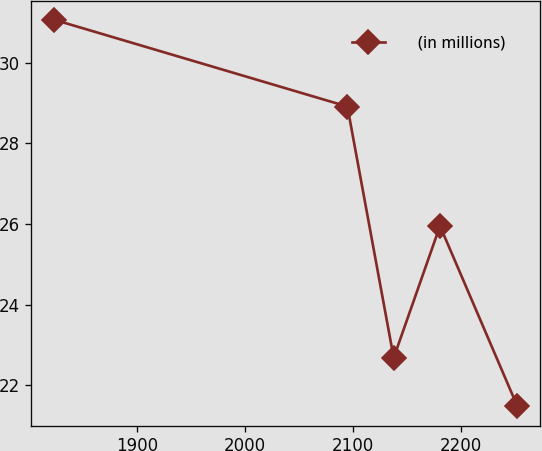<chart> <loc_0><loc_0><loc_500><loc_500><line_chart><ecel><fcel>(in millions)<nl><fcel>1823.63<fcel>31.06<nl><fcel>2094.83<fcel>28.91<nl><fcel>2137.68<fcel>22.68<nl><fcel>2180.53<fcel>25.95<nl><fcel>2252.11<fcel>21.48<nl></chart> 